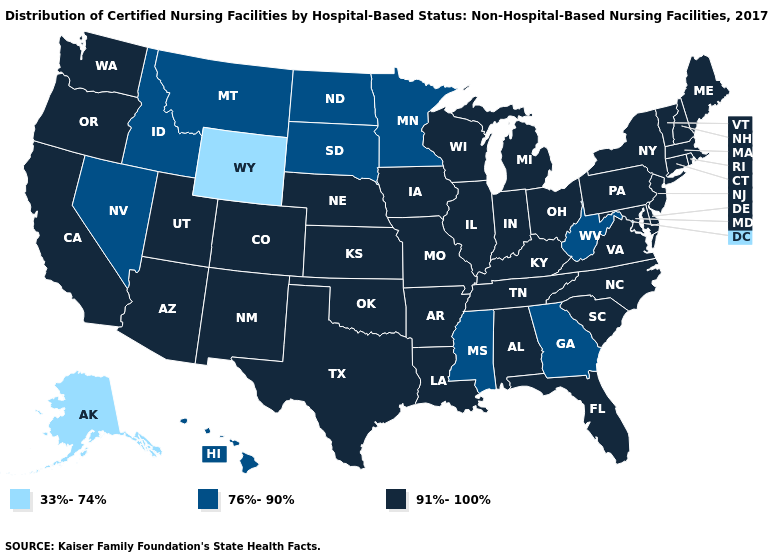Does the first symbol in the legend represent the smallest category?
Write a very short answer. Yes. Name the states that have a value in the range 76%-90%?
Be succinct. Georgia, Hawaii, Idaho, Minnesota, Mississippi, Montana, Nevada, North Dakota, South Dakota, West Virginia. Name the states that have a value in the range 76%-90%?
Quick response, please. Georgia, Hawaii, Idaho, Minnesota, Mississippi, Montana, Nevada, North Dakota, South Dakota, West Virginia. Among the states that border Oregon , which have the highest value?
Write a very short answer. California, Washington. What is the value of Alaska?
Give a very brief answer. 33%-74%. Which states have the lowest value in the USA?
Quick response, please. Alaska, Wyoming. What is the value of Vermont?
Keep it brief. 91%-100%. Name the states that have a value in the range 76%-90%?
Short answer required. Georgia, Hawaii, Idaho, Minnesota, Mississippi, Montana, Nevada, North Dakota, South Dakota, West Virginia. Name the states that have a value in the range 76%-90%?
Keep it brief. Georgia, Hawaii, Idaho, Minnesota, Mississippi, Montana, Nevada, North Dakota, South Dakota, West Virginia. Name the states that have a value in the range 33%-74%?
Concise answer only. Alaska, Wyoming. What is the value of North Dakota?
Concise answer only. 76%-90%. How many symbols are there in the legend?
Write a very short answer. 3. Among the states that border Idaho , which have the highest value?
Concise answer only. Oregon, Utah, Washington. Does Michigan have the lowest value in the USA?
Keep it brief. No. What is the value of Iowa?
Be succinct. 91%-100%. 